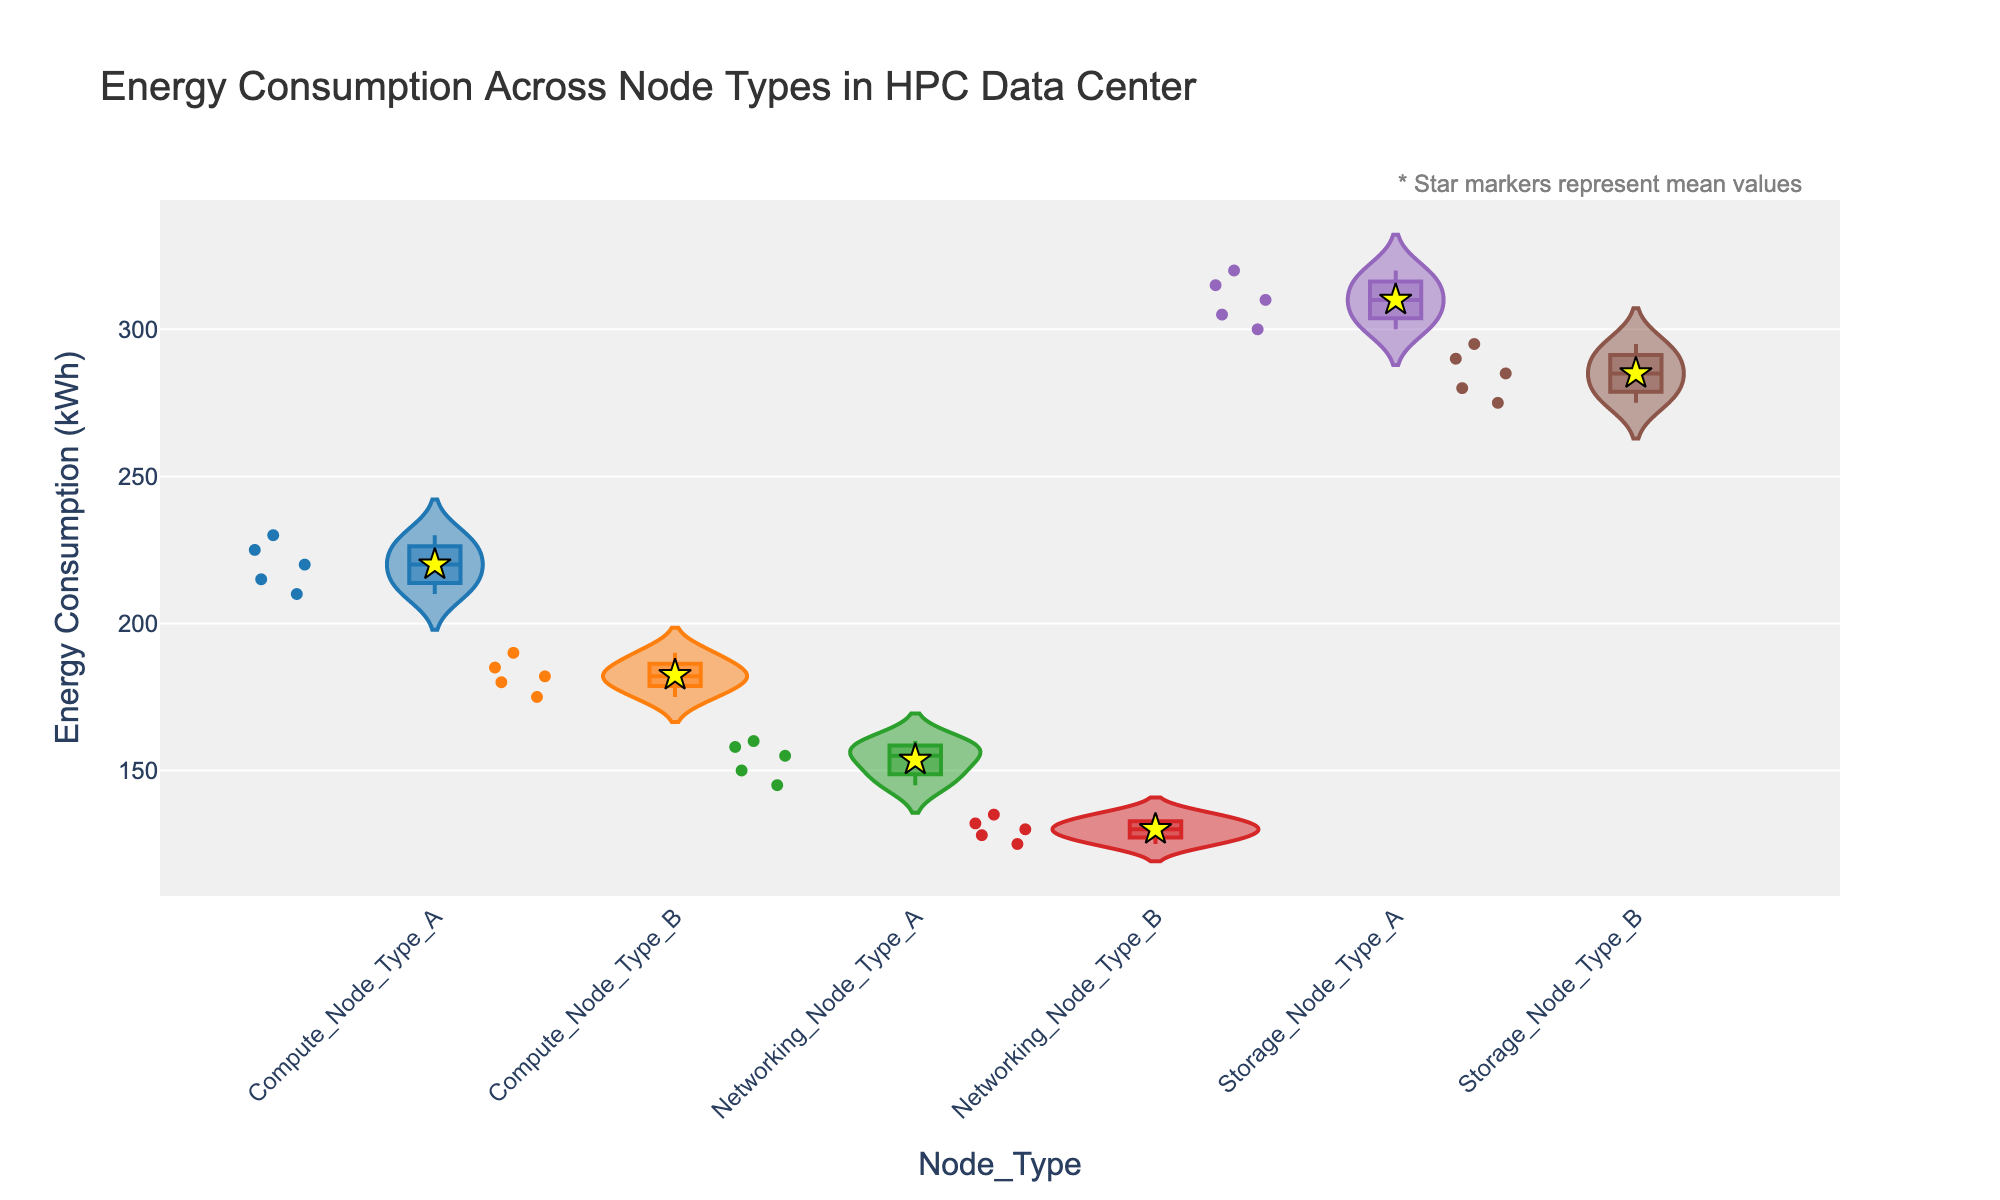What is the title of the violin chart? The title is usually placed at the top of the chart. From the provided code, the title is set to "Energy Consumption Across Node Types in HPC Data Center".
Answer: Energy Consumption Across Node Types in HPC Data Center How many different node types are displayed in the chart? Each unique node type corresponds to a separate entry in the legend or x-axis. From the code and data, the node types include Compute_Node_Type_A, Compute_Node_Type_B, Storage_Node_Type_A, Storage_Node_Type_B, Networking_Node_Type_A, and Networking_Node_Type_B. Counting these, we have 6 node types.
Answer: 6 Which node type has the highest mean energy consumption? Look for the star markers on the plot which represent the mean values. The highest position among these stars will indicate the highest mean energy consumption. From the data, Storage_Node_Type_A and Storage_Node_Type_B have high values, but Storage_Node_Type_A is higher.
Answer: Storage_Node_Type_A What is the median energy consumption for Compute_Node_Type_A? The median is represented by the horizontal line inside the box in each violin. For Compute_Node_Type_A, this value can be seen directly from the chart.
Answer: 220 kWh How does Storage_Node_Type_B's mean energy consumption compare to Compute_Node_Type_B's mean energy consumption? Compare the star markers representing the mean values for Storage_Node_Type_B and Compute_Node_Type_B. The mean value for Storage_Node_Type_B is higher than that of Compute_Node_Type_B.
Answer: Storage_Node_Type_B's mean is higher What is the general distribution shape of Networking_Node_Type_A's energy consumption? Violin plots show the distribution shape by the width of the plot. For Networking_Node_Type_A, if the width is spread more in the center, it's more concentrated around the median.
Answer: Symmetric around the median Which node types have the lowest and highest median energy consumption values? Look for the horizontal lines within the boxes. The lowest median is for Networking_Node_Type_B and the highest median is for Storage_Node_Type_A.
Answer: Networking_Node_Type_B and Storage_Node_Type_A respectively How many data points are shown for Compute_Node_Type_B? For each node type, count the visible data point markers on the plot. Compute_Node_Type_B has five data points shown.
Answer: 5 What color represents the Networking_Node_Type_A in the plot? The provided code specifies a custom color palette, and by checking the displayed plot, we can associate the colors with the node types. Networking_Node_Type_A is the first node type listed after Storage_Node, which is likely represented in a distinguishable color like blue or orange from the palette sequence.
Answer: Blue (or respective first color assigned) What is the interquartile range (IQR) for Storage_Node_Type_A? The IQR is the difference between the third quartile (Q3) and the first quartile (Q1). From the chart, identify the values at the top and bottom of the box for Storage_Node_Type_A. Q3 might be around 315 kWh and Q1 around 305 kWh.
Answer: Approximately 10 kWh 